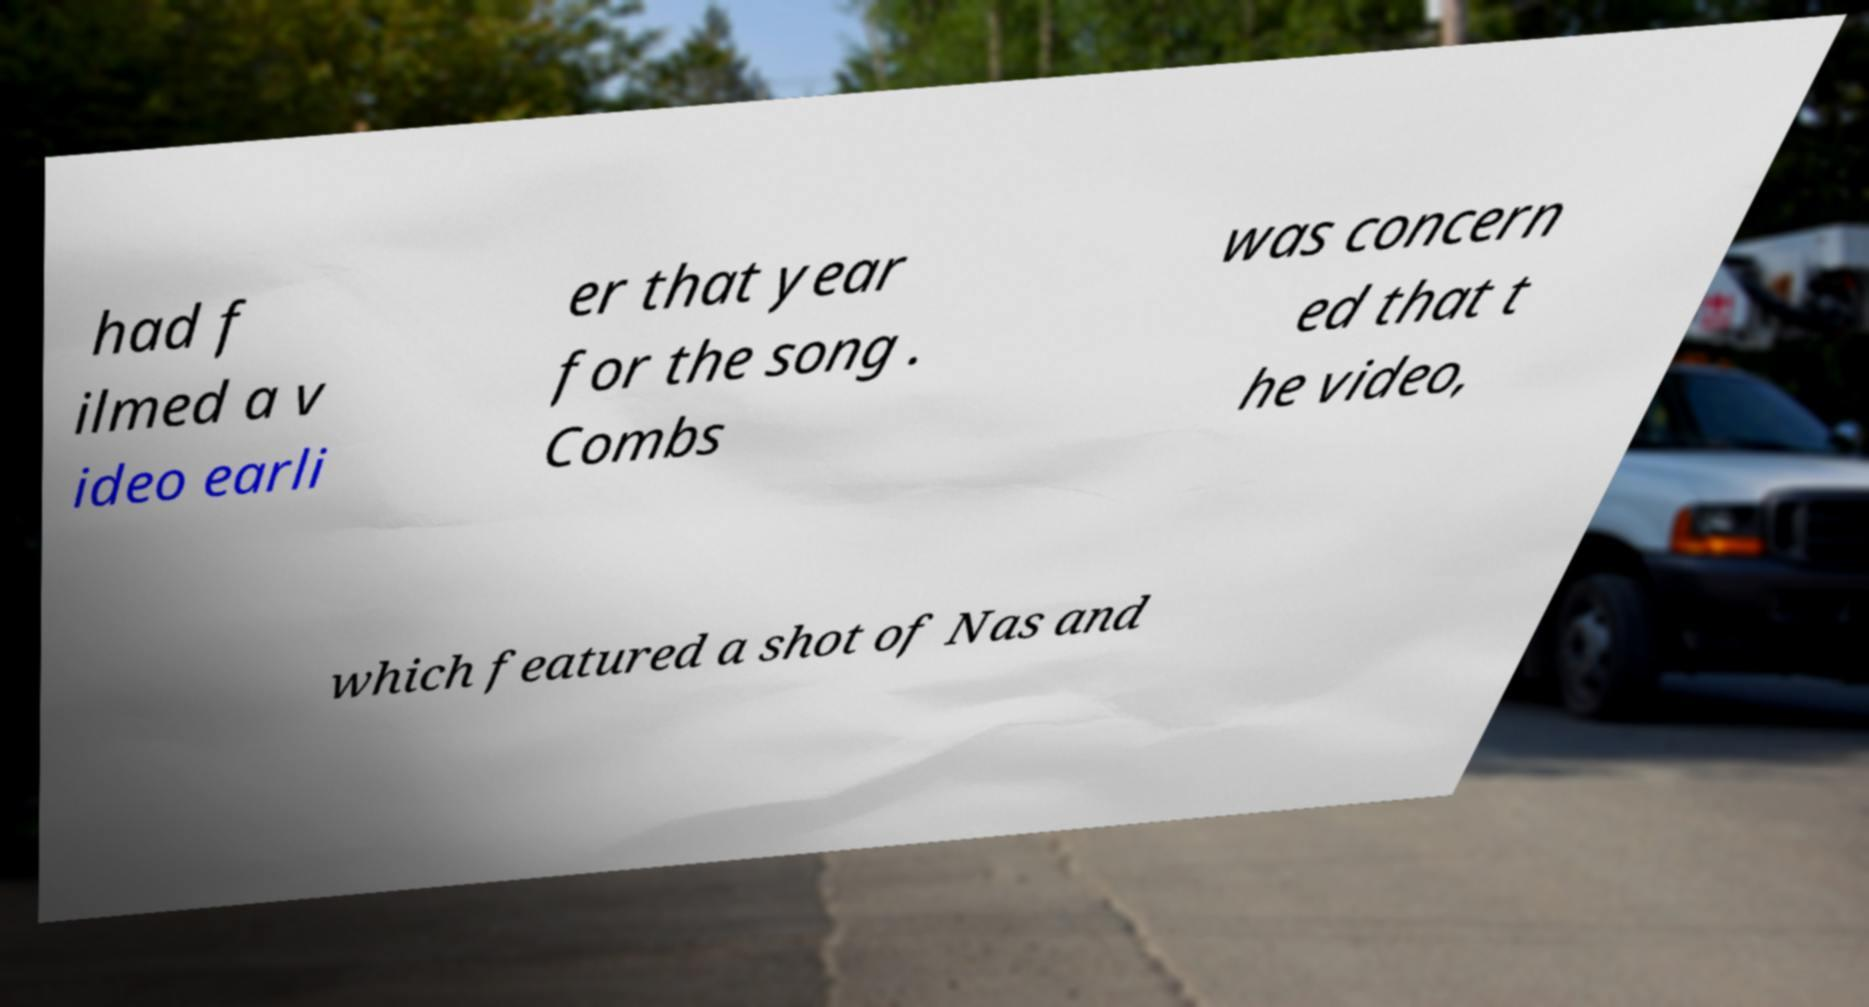Could you assist in decoding the text presented in this image and type it out clearly? had f ilmed a v ideo earli er that year for the song . Combs was concern ed that t he video, which featured a shot of Nas and 